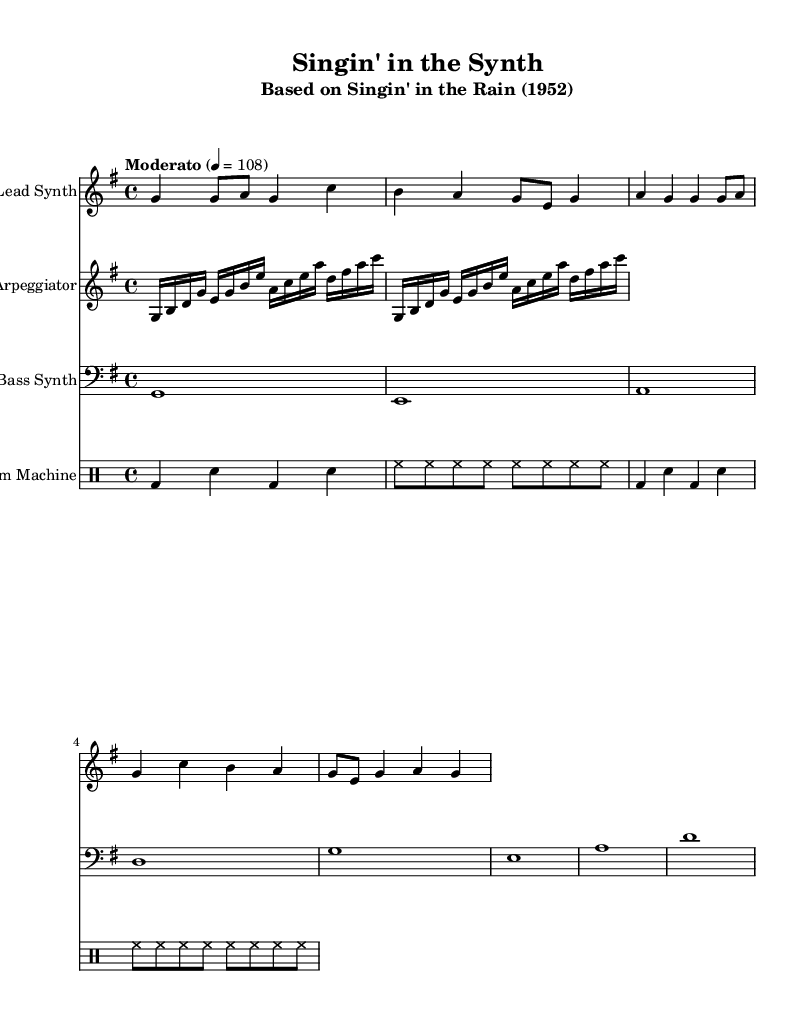What is the key signature of this music? The key signature is G major, which has one sharp (F#). This can be identified by looking at the key signature marking at the beginning of the staff, which shows one sharp.
Answer: G major What is the time signature of this piece? The time signature is 4/4, which is indicated at the beginning of the score as a fraction representing four beats per measure. Each measure contains four quarter notes.
Answer: 4/4 What is the tempo marking for this composition? The tempo marking is "Moderato," with a specific speed of 108 beats per minute. This information is found in the tempo marking that accompanies the time signature at the start of the sheet music.
Answer: Moderato How many measures are in the lead synth part? The lead synth part contains eight measures, which can be counted by the divisions seen on the staff where the notes are played. Each group of notes represents a measure.
Answer: Eight measures What type of drum pattern is primarily used? The drum pattern consists of bass drum and snare drum hits in a standard four-beat pattern. This is derived from examining the drum staff where the pattern is notated, showing the alternating bass and snare hits in repeating segments.
Answer: Bass and snare How many notes are in the arpeggiator section? The arpeggiator section has twelve notes, counted by examining each note symbol written in that part of the sheet music. Each distinct note and its repetitions are totaled to give the count.
Answer: Twelve notes What genre does this piece represent? This piece represents the electronic genre, specifically through its synthesizer-driven interpretation of a classic Hollywood musical theme. This genre is indicated by the instrumentation and the style of music presented in the score.
Answer: Electronic 